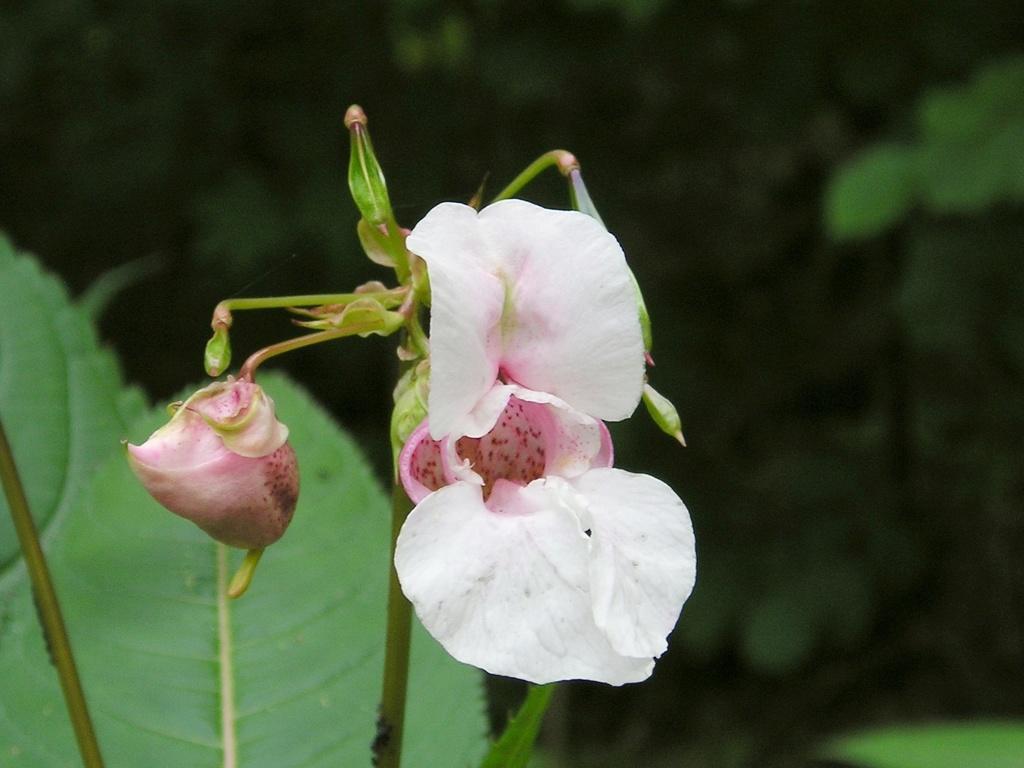In one or two sentences, can you explain what this image depicts? In this image we can see a plant with flowers and bud. In the background the image is blur but we can see the leaf and plants. 